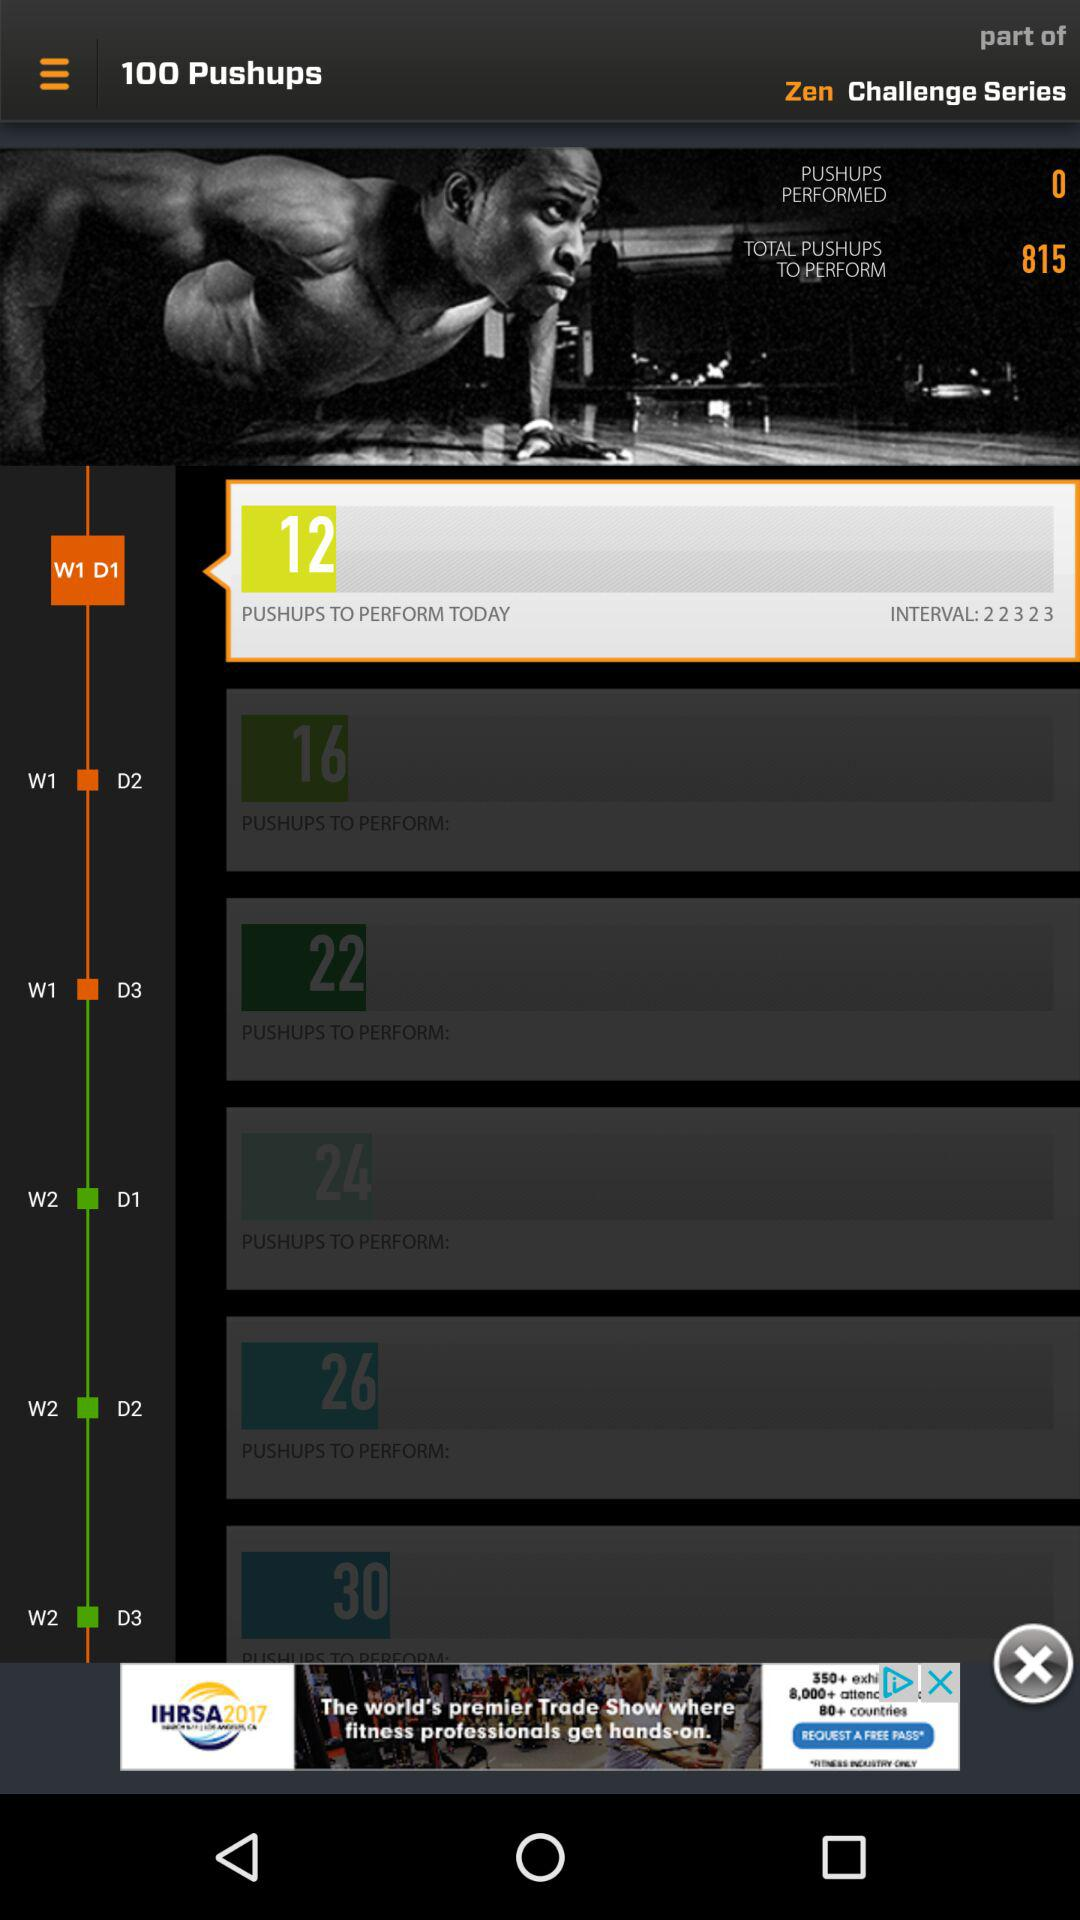How many weeks are in this challenge?
Answer the question using a single word or phrase. 2 